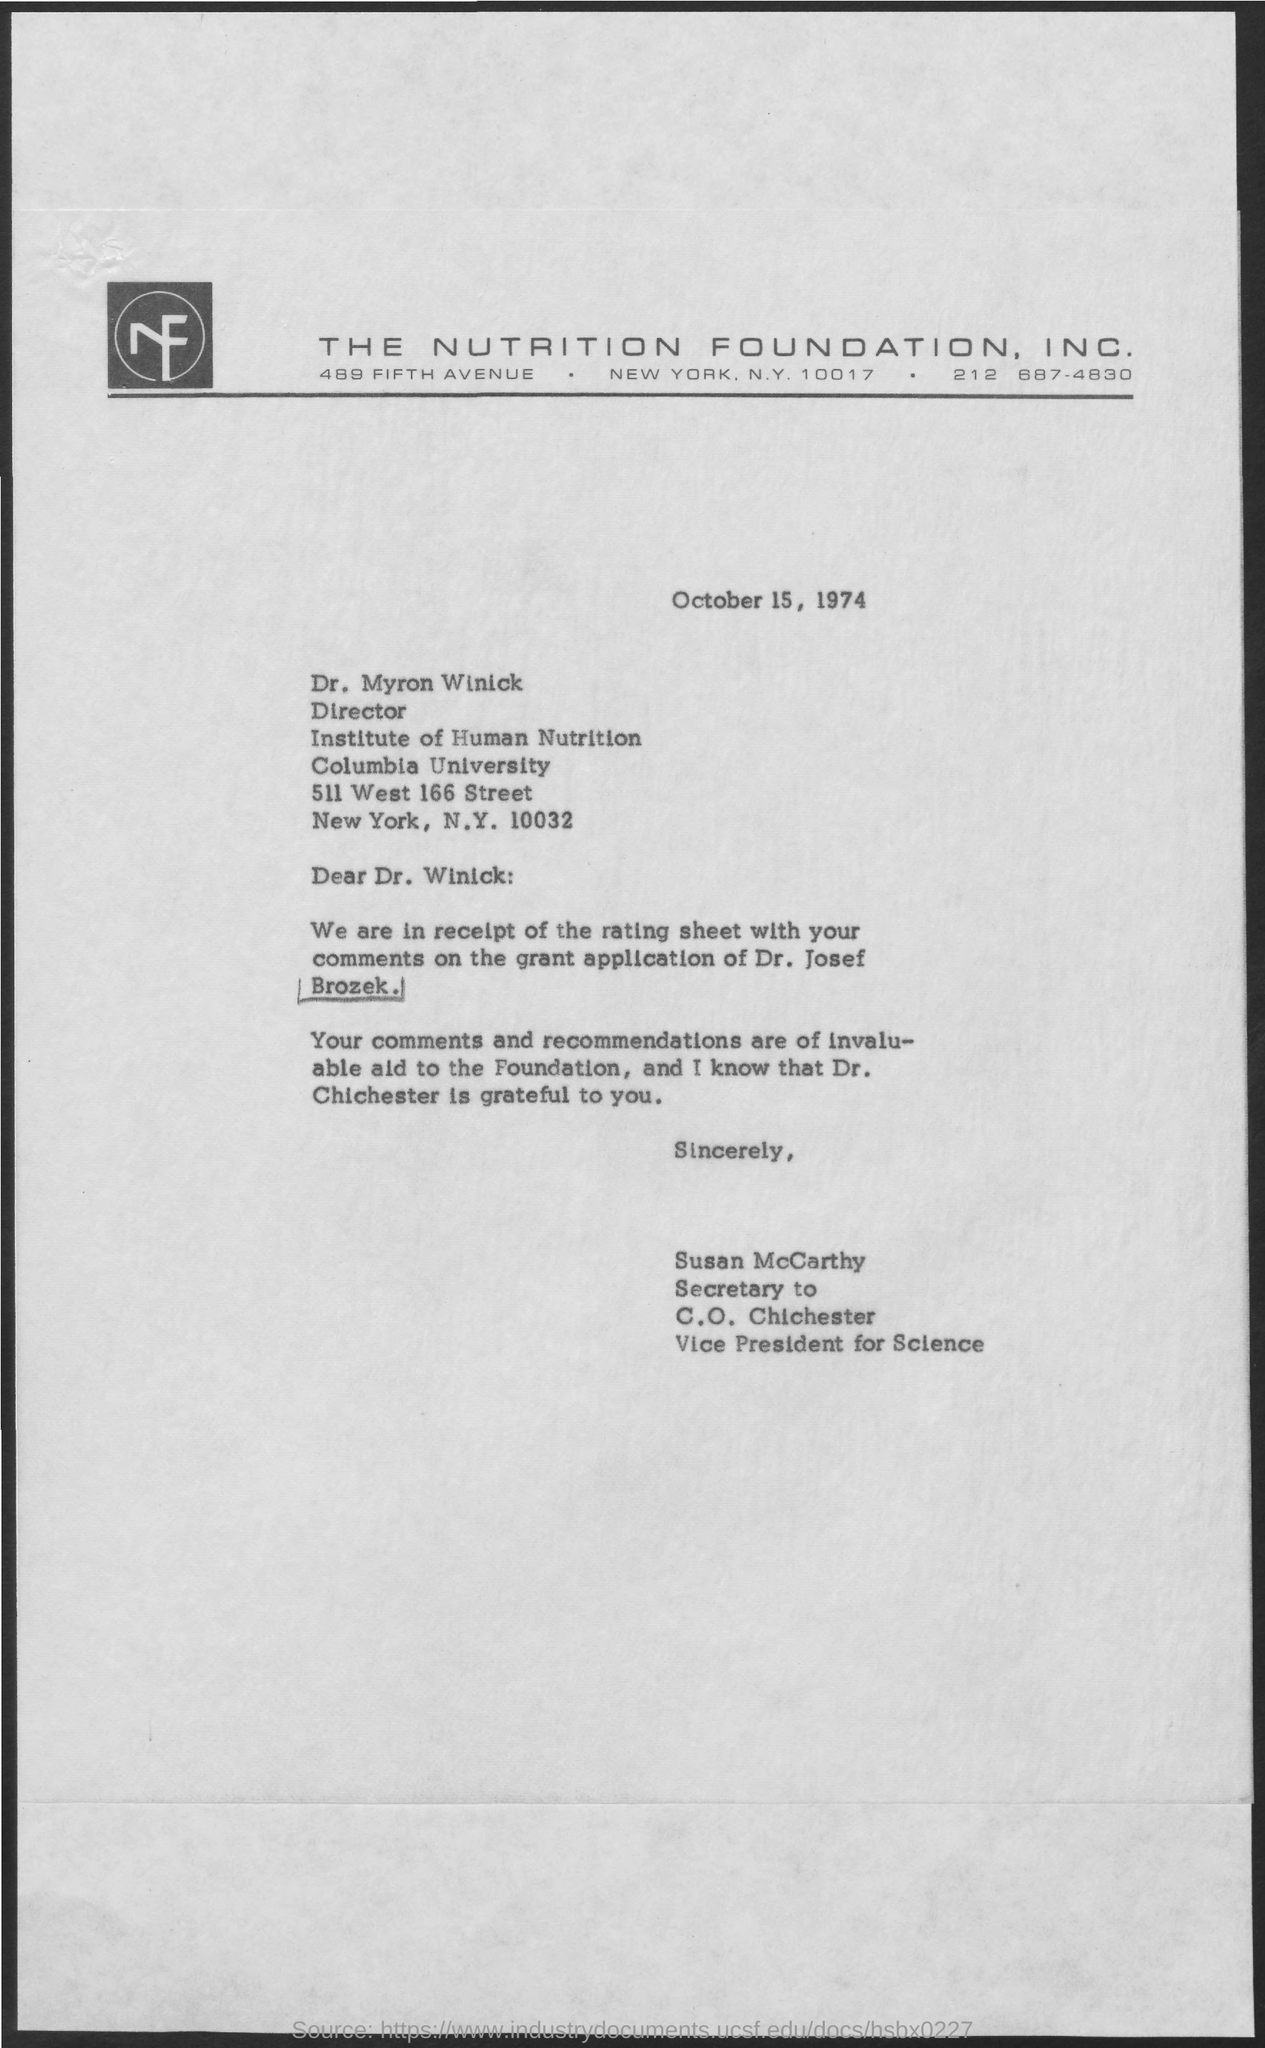Specify some key components in this picture. Dr. Chichester is grateful for the recommendations. The letter is addressed to Dr. Myron Winick. 